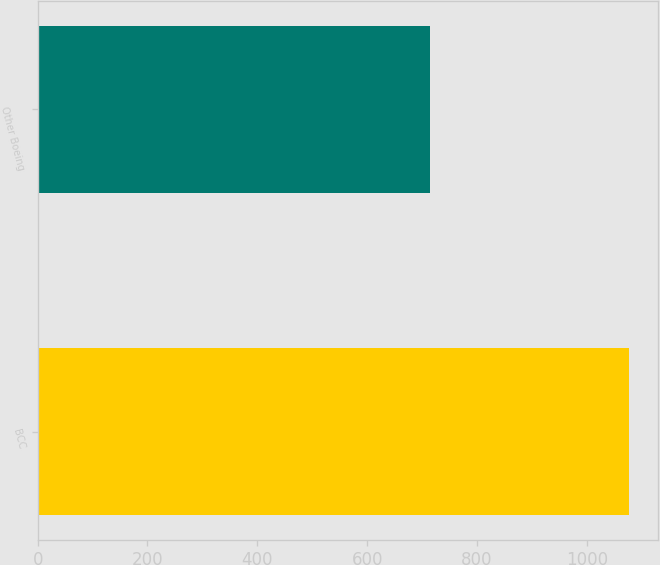<chart> <loc_0><loc_0><loc_500><loc_500><bar_chart><fcel>BCC<fcel>Other Boeing<nl><fcel>1076<fcel>714<nl></chart> 